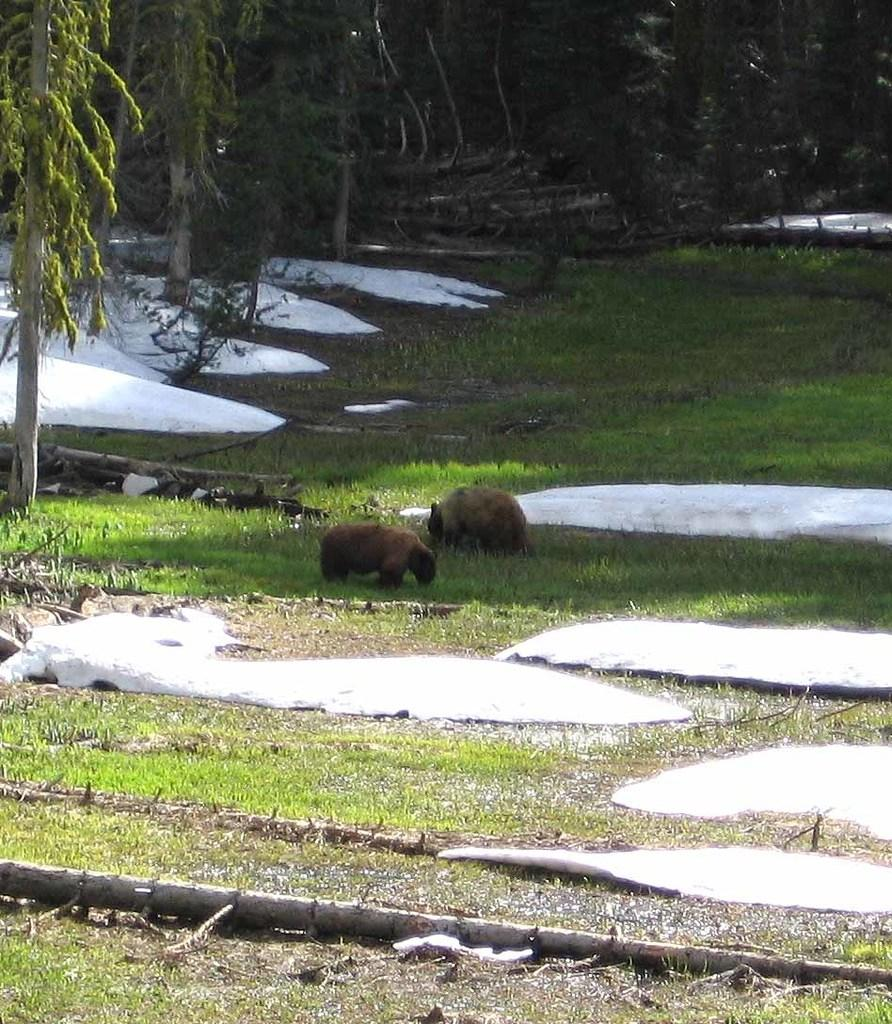What can be seen on the ground in the image? There are two animals on the ground in the image. What is the setting of the image? Snow is visible in the background of the image, along with grass and a group of trees. What else can be seen on the ground in the background of the image? Wood logs are on the ground in the background of the image. What type of lettuce is being used as a toothpick in the image? There is no lettuce or toothpick present in the image. What event led to the death of the animals in the image? There is no indication of any event or death in the image; it simply shows two animals on the ground. 